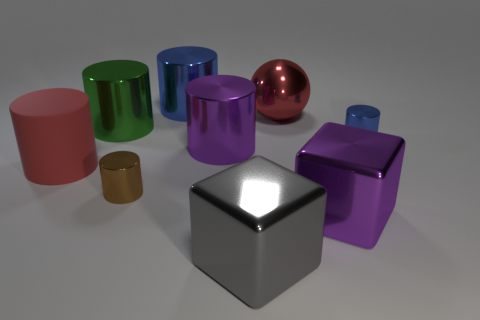Is there anything else that is the same material as the big red cylinder?
Your answer should be compact. No. How many big gray shiny objects are the same shape as the big blue object?
Make the answer very short. 0. What is the big thing that is both in front of the purple cylinder and left of the brown metal thing made of?
Offer a very short reply. Rubber. What number of brown cylinders are to the right of the rubber cylinder?
Give a very brief answer. 1. How many blocks are there?
Ensure brevity in your answer.  2. Is the size of the green shiny cylinder the same as the rubber cylinder?
Your answer should be compact. Yes. Are there any big red cylinders left of the small metallic cylinder that is on the left side of the big purple cube in front of the large green thing?
Provide a succinct answer. Yes. What is the material of the big red object that is the same shape as the small brown metal object?
Ensure brevity in your answer.  Rubber. The small metallic object on the right side of the gray block is what color?
Make the answer very short. Blue. What size is the brown metallic cylinder?
Make the answer very short. Small. 